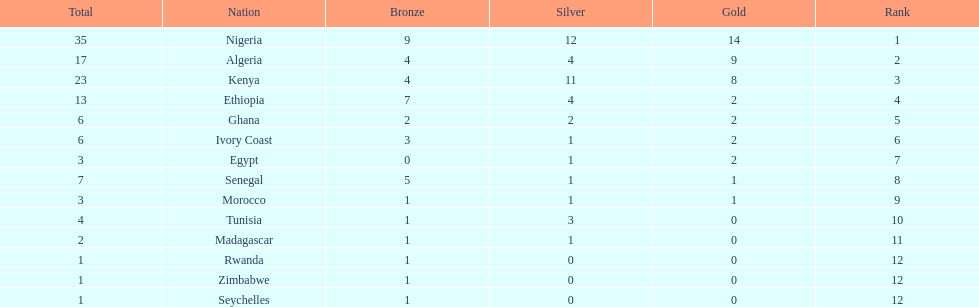What is the total number of countries that have achieved any medal winnings? 14. 